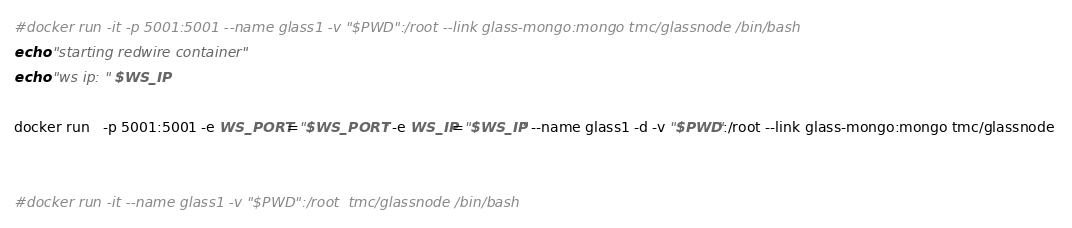Convert code to text. <code><loc_0><loc_0><loc_500><loc_500><_Bash_>#docker run -it -p 5001:5001 --name glass1 -v "$PWD":/root --link glass-mongo:mongo tmc/glassnode /bin/bash
echo "starting redwire container"
echo "ws ip: " $WS_IP

docker run   -p 5001:5001 -e WS_PORT="$WS_PORT" -e WS_IP="$WS_IP" --name glass1 -d -v "$PWD":/root --link glass-mongo:mongo tmc/glassnode 


#docker run -it --name glass1 -v "$PWD":/root  tmc/glassnode /bin/bash
</code> 